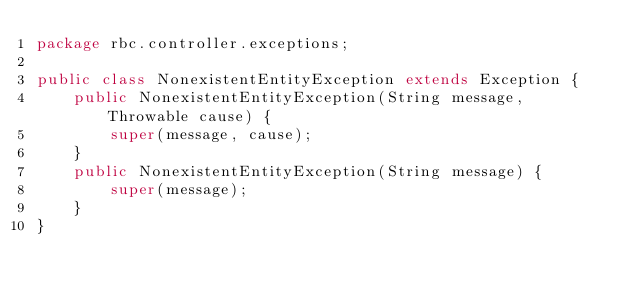Convert code to text. <code><loc_0><loc_0><loc_500><loc_500><_Java_>package rbc.controller.exceptions;

public class NonexistentEntityException extends Exception {
    public NonexistentEntityException(String message, Throwable cause) {
        super(message, cause);
    }
    public NonexistentEntityException(String message) {
        super(message);
    }
}
</code> 